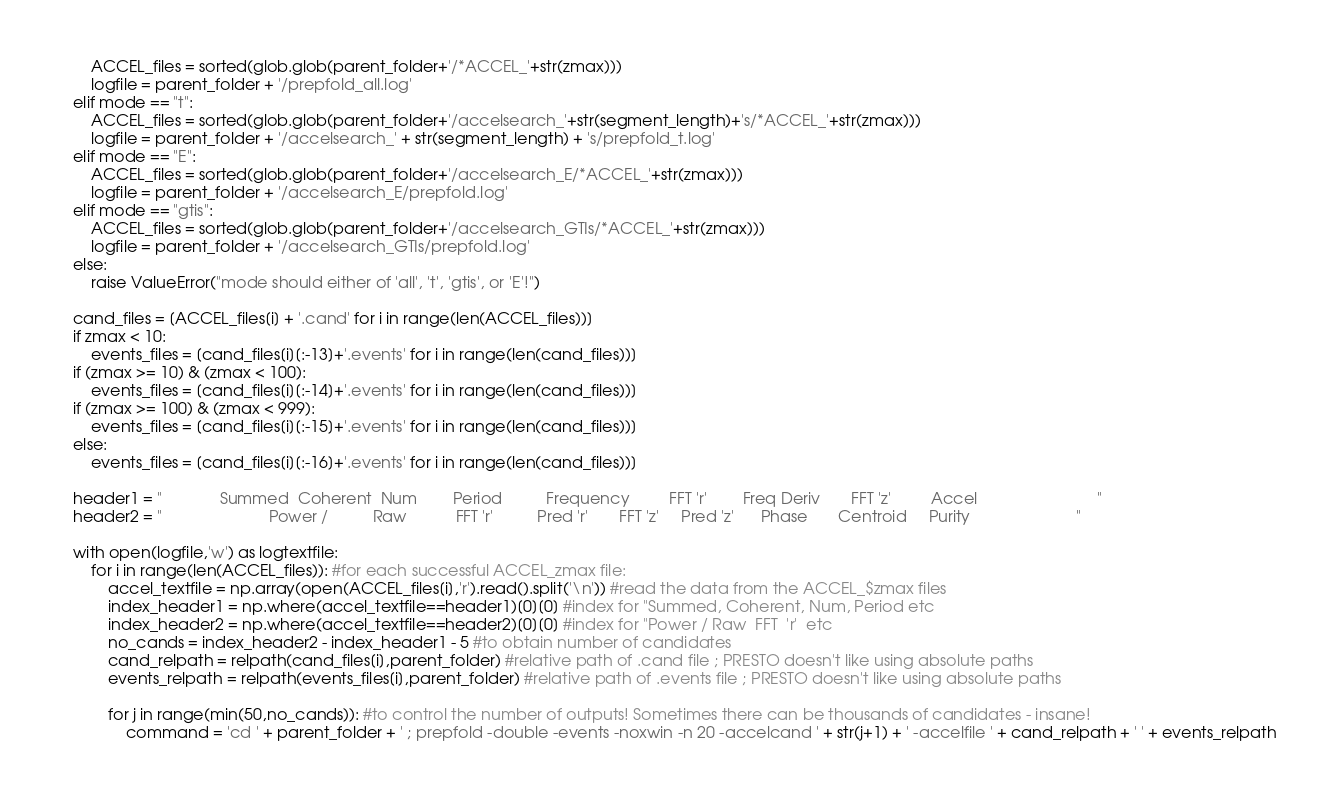<code> <loc_0><loc_0><loc_500><loc_500><_Python_>        ACCEL_files = sorted(glob.glob(parent_folder+'/*ACCEL_'+str(zmax)))
        logfile = parent_folder + '/prepfold_all.log'
    elif mode == "t":
        ACCEL_files = sorted(glob.glob(parent_folder+'/accelsearch_'+str(segment_length)+'s/*ACCEL_'+str(zmax)))
        logfile = parent_folder + '/accelsearch_' + str(segment_length) + 's/prepfold_t.log'
    elif mode == "E":
        ACCEL_files = sorted(glob.glob(parent_folder+'/accelsearch_E/*ACCEL_'+str(zmax)))
        logfile = parent_folder + '/accelsearch_E/prepfold.log'
    elif mode == "gtis":
        ACCEL_files = sorted(glob.glob(parent_folder+'/accelsearch_GTIs/*ACCEL_'+str(zmax)))
        logfile = parent_folder + '/accelsearch_GTIs/prepfold.log'
    else:
        raise ValueError("mode should either of 'all', 't', 'gtis', or 'E'!")

    cand_files = [ACCEL_files[i] + '.cand' for i in range(len(ACCEL_files))]
    if zmax < 10:
        events_files = [cand_files[i][:-13]+'.events' for i in range(len(cand_files))]
    if (zmax >= 10) & (zmax < 100):
        events_files = [cand_files[i][:-14]+'.events' for i in range(len(cand_files))]
    if (zmax >= 100) & (zmax < 999):
        events_files = [cand_files[i][:-15]+'.events' for i in range(len(cand_files))]
    else:
        events_files = [cand_files[i][:-16]+'.events' for i in range(len(cand_files))]

    header1 = "             Summed  Coherent  Num        Period          Frequency         FFT 'r'        Freq Deriv       FFT 'z'         Accel                           "
    header2 = "                        Power /          Raw           FFT 'r'          Pred 'r'       FFT 'z'     Pred 'z'      Phase       Centroid     Purity                        "

    with open(logfile,'w') as logtextfile:
        for i in range(len(ACCEL_files)): #for each successful ACCEL_zmax file:
            accel_textfile = np.array(open(ACCEL_files[i],'r').read().split('\n')) #read the data from the ACCEL_$zmax files
            index_header1 = np.where(accel_textfile==header1)[0][0] #index for "Summed, Coherent, Num, Period etc
            index_header2 = np.where(accel_textfile==header2)[0][0] #index for "Power / Raw  FFT  'r'  etc
            no_cands = index_header2 - index_header1 - 5 #to obtain number of candidates
            cand_relpath = relpath(cand_files[i],parent_folder) #relative path of .cand file ; PRESTO doesn't like using absolute paths
            events_relpath = relpath(events_files[i],parent_folder) #relative path of .events file ; PRESTO doesn't like using absolute paths

            for j in range(min(50,no_cands)): #to control the number of outputs! Sometimes there can be thousands of candidates - insane!
                command = 'cd ' + parent_folder + ' ; prepfold -double -events -noxwin -n 20 -accelcand ' + str(j+1) + ' -accelfile ' + cand_relpath + ' ' + events_relpath</code> 